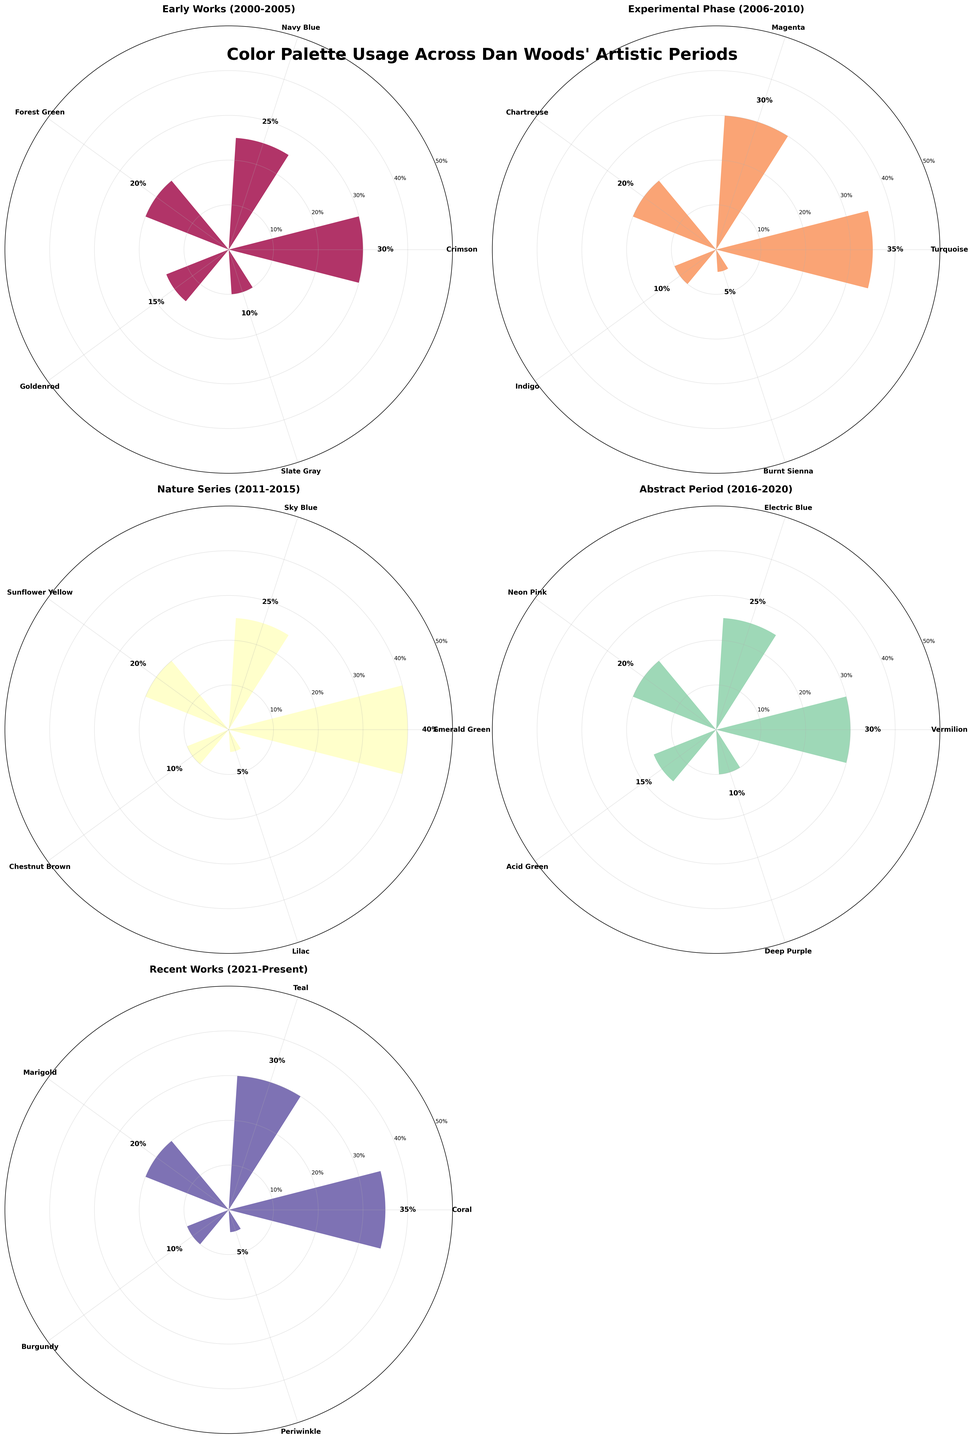What's the overall title of the figure? The overall title is located at the top of the figure, summarizing the visual data presented. It reads "Color Palette Usage Across Dan Woods' Artistic Periods".
Answer: Color Palette Usage Across Dan Woods' Artistic Periods Which artistic period used Emerald Green the most? Observing the labels in the "Nature Series (2011-2015)" section, Emerald Green has the highest percentage of 40%, making it the dominant color in this specific period.
Answer: Nature Series (2011-2015) How many colors were used in total for the "Experimental Phase (2006-2010)"? Counting the bars in the "Experimental Phase (2006-2010)" section reveals five different colors. These are Turquoise, Magenta, Chartreuse, Indigo, and Burnt Sienna.
Answer: Five Which color was used the least in "Early Works (2000-2005)" and its percentage? In the "Early Works (2000-2005)", Slate Gray is the color with the smallest bar. The percentage next to it reads 10%.
Answer: Slate Gray, 10% Compare the color usage of "Vermilion" and "Neon Pink" in the "Abstract Period (2016-2020)". Which one is higher and by how much? In the "Abstract Period (2016-2020)", Vermilion (30%) is higher than Neon Pink (20%), which can be directly compared by calculating the difference. 30% - 20% = 10%.
Answer: Vermilion, 10% What is the average percentage of color usage in the "Recent Works (2021-Present)"? Summing up the percentages in "Recent Works (2021-Present)" gives (35 + 30 + 20 + 10 + 5) = 100%. There are 5 colors here, so the average is 100% / 5 = 20%.
Answer: 20% Which period shows the highest single color usage and which color is it? By comparing the highest bars from each period, "Emerald Green" in "Nature Series (2011-2015)" stands out with 40%.
Answer: Nature Series (2011-2015), Emerald Green How does the color distribution in "Nature Series (2011-2015)" compare to "Abstract Period (2016-2020)" in terms of diversity? Counting the number of colors and examining the range of percentages: both periods have five colors, but "Nature Series (2011-2015)" has a wider range with a top bar at 40%, while "Abstract Period (2016-2020)" has its highest at 30%.
Answer: Nature Series has greater diversity Which period used Turquoise the most and its percentage? Checking the periods individually, "Experimental Phase (2006-2010)" highlights Turquoise with a percentage of 35%, as indicated at the top of the corresponding bar.
Answer: Experimental Phase (2006-2010), 35% Is the usage of Crimson in the "Early Works (2000-2005)" greater or less than Teal in the "Recent Works (2021-Present)"? Comparing the percentages, Crimson (30%) from "Early Works (2000-2005)" is less than Teal (30%) from "Recent Works (2021-Present)".
Answer: Less 